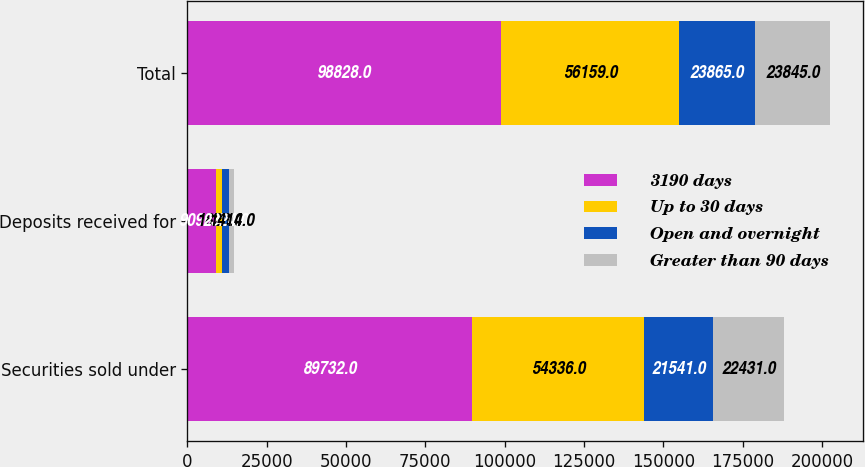<chart> <loc_0><loc_0><loc_500><loc_500><stacked_bar_chart><ecel><fcel>Securities sold under<fcel>Deposits received for<fcel>Total<nl><fcel>3190 days<fcel>89732<fcel>9096<fcel>98828<nl><fcel>Up to 30 days<fcel>54336<fcel>1823<fcel>56159<nl><fcel>Open and overnight<fcel>21541<fcel>2324<fcel>23865<nl><fcel>Greater than 90 days<fcel>22431<fcel>1414<fcel>23845<nl></chart> 